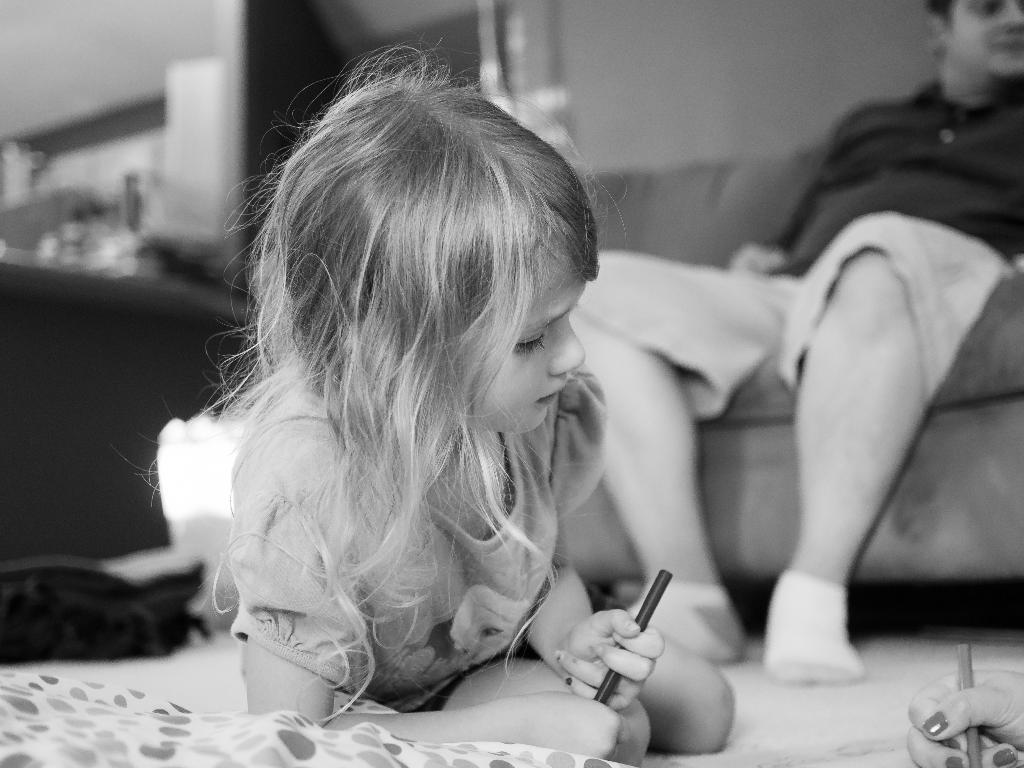Who is the main subject in the middle of the image? There is a girl in the middle of the image. What can be seen on the right side of the image? There is a person sitting on the sofa on the right side of the image. What is the color scheme of the image? The image is black and white. What type of protest is happening in the image? There is no protest present in the image; it features a girl in the middle and a person sitting on the sofa on the right side. Can you hear the voice of the girl in the image? The image is a still photograph, so there is no sound or voice present. 